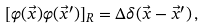<formula> <loc_0><loc_0><loc_500><loc_500>[ \varphi ( \vec { x } ) \varphi ( \vec { x } ^ { \prime } ) ] _ { R } = \Delta \delta ( \vec { x } - \vec { x } ^ { \prime } ) \, ,</formula> 